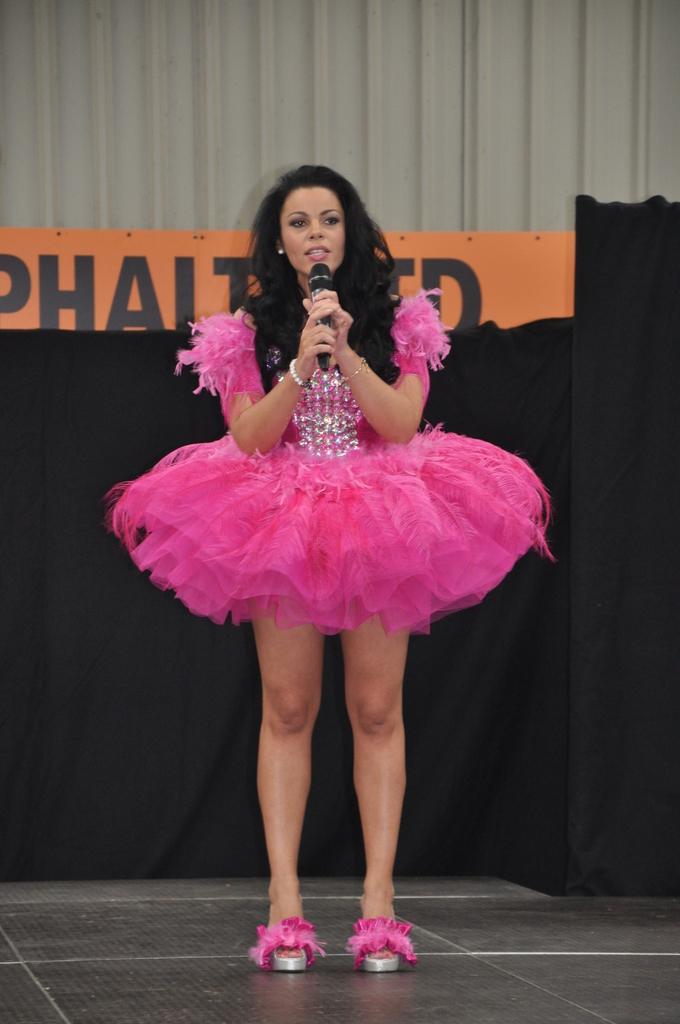Could you give a brief overview of what you see in this image? In the picture I can see a woman is standing on the floor and holding a microphone in hands. The woman is wearing pink color clothes. In the background I can see something written on the object. 